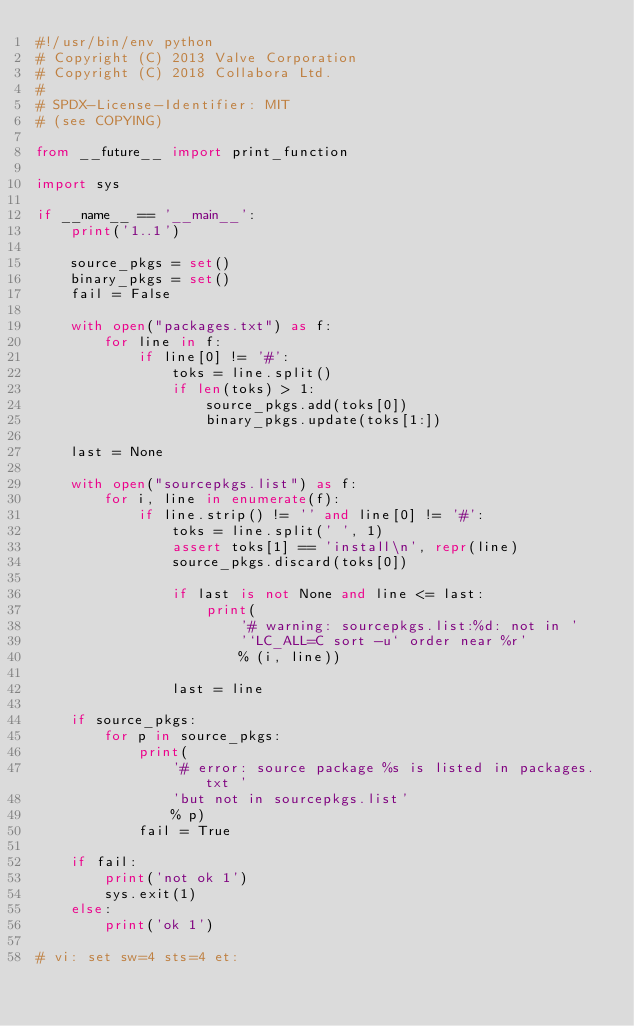Convert code to text. <code><loc_0><loc_0><loc_500><loc_500><_Python_>#!/usr/bin/env python
# Copyright (C) 2013 Valve Corporation
# Copyright (C) 2018 Collabora Ltd.
#
# SPDX-License-Identifier: MIT
# (see COPYING)

from __future__ import print_function

import sys

if __name__ == '__main__':
    print('1..1')

    source_pkgs = set()
    binary_pkgs = set()
    fail = False

    with open("packages.txt") as f:
        for line in f:
            if line[0] != '#':
                toks = line.split()
                if len(toks) > 1:
                    source_pkgs.add(toks[0])
                    binary_pkgs.update(toks[1:])

    last = None

    with open("sourcepkgs.list") as f:
        for i, line in enumerate(f):
            if line.strip() != '' and line[0] != '#':
                toks = line.split(' ', 1)
                assert toks[1] == 'install\n', repr(line)
                source_pkgs.discard(toks[0])

                if last is not None and line <= last:
                    print(
                        '# warning: sourcepkgs.list:%d: not in '
                        '`LC_ALL=C sort -u` order near %r'
                        % (i, line))

                last = line

    if source_pkgs:
        for p in source_pkgs:
            print(
                '# error: source package %s is listed in packages.txt '
                'but not in sourcepkgs.list'
                % p)
            fail = True

    if fail:
        print('not ok 1')
        sys.exit(1)
    else:
        print('ok 1')

# vi: set sw=4 sts=4 et:
</code> 